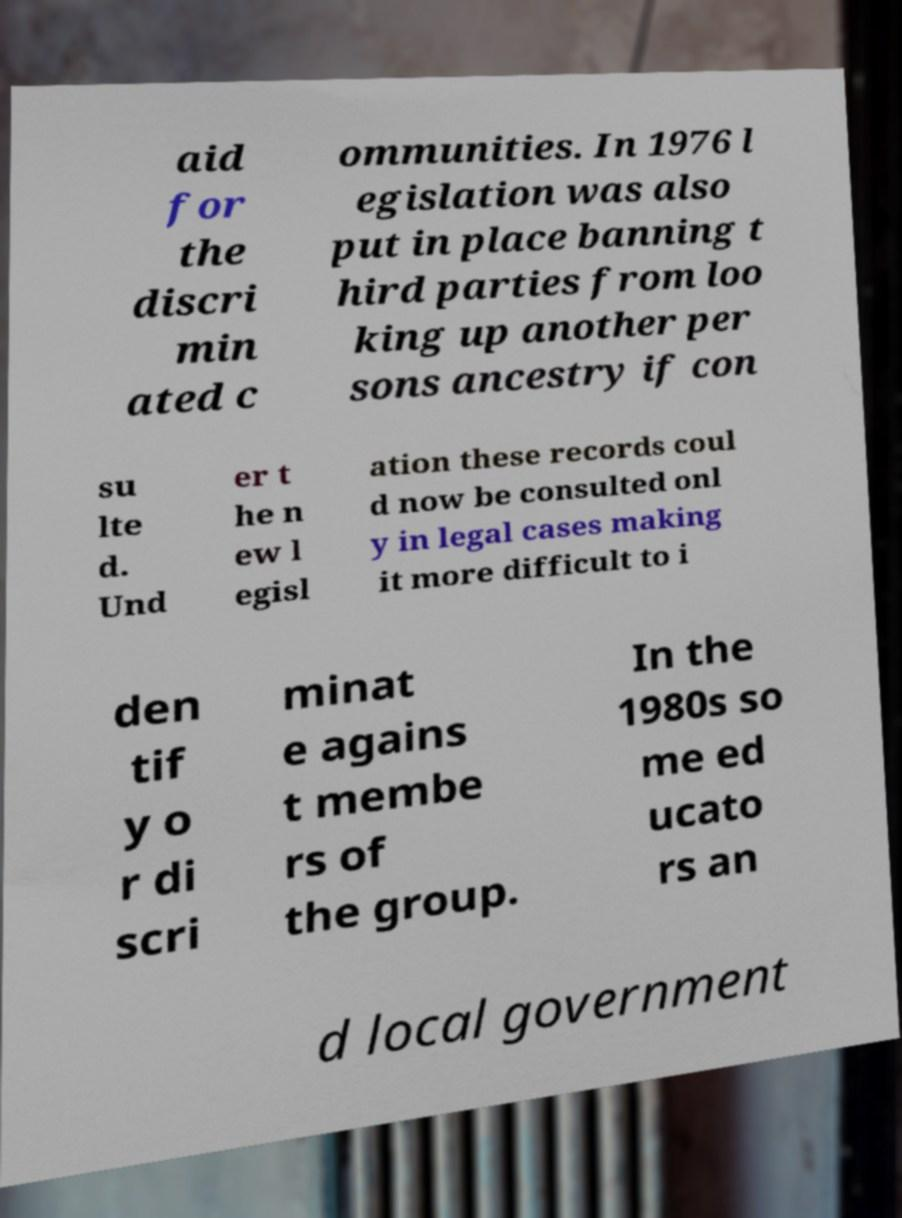Can you accurately transcribe the text from the provided image for me? aid for the discri min ated c ommunities. In 1976 l egislation was also put in place banning t hird parties from loo king up another per sons ancestry if con su lte d. Und er t he n ew l egisl ation these records coul d now be consulted onl y in legal cases making it more difficult to i den tif y o r di scri minat e agains t membe rs of the group. In the 1980s so me ed ucato rs an d local government 